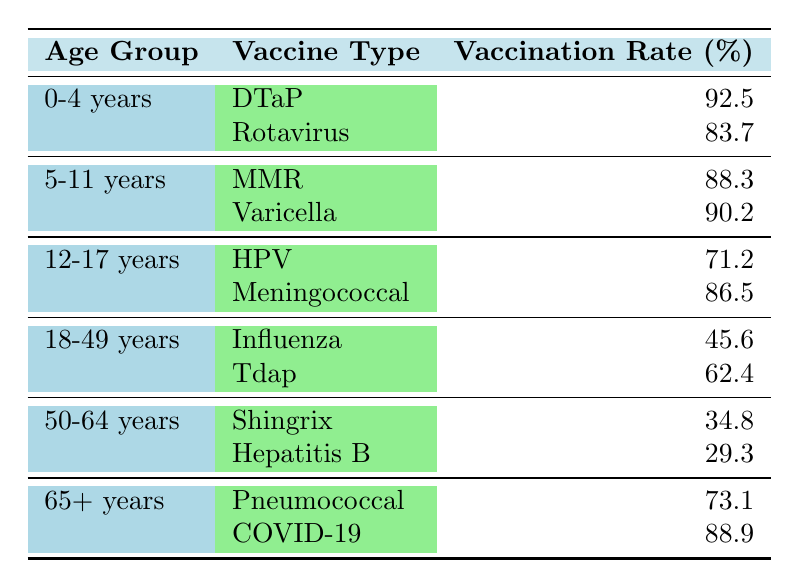What is the vaccination rate for DTaP in the 0-4 years age group? The table shows that the vaccination rate for DTaP in the 0-4 years age group is listed directly as 92.5%.
Answer: 92.5% Which age group has the highest vaccination rate for Varicella? Varicella's vaccination rate is listed under the 5-11 years age group at 90.2%, which is the highest among the listed age groups for this vaccine.
Answer: 5-11 years What is the average vaccination rate for the 18-49 years age group? The vaccination rates for the 18-49 years age group are 45.6% for Influenza and 62.4% for Tdap. The average is calculated as (45.6 + 62.4) / 2 = 54%.
Answer: 54% Is the vaccination rate for HPV higher or lower than that for Meningococcal in the 12-17 years age group? The rate for HPV is 71.2% while Meningococcal is 86.5%. Since 71.2% is less than 86.5%, the HPV rate is lower.
Answer: Lower What are the two vaccines received by the 65+ years age group? The table lists Pneumococcal and COVID-19 for the 65+ years age group.
Answer: Pneumococcal and COVID-19 Which age group has the lowest overall vaccination rates? In the 50-64 years age group, both vaccines (Shingrix at 34.8% and Hepatitis B at 29.3%) have the lowest rates compared to other age groups.
Answer: 50-64 years If you combine the vaccination rates for 0-4 years, what is the total? The total is found by adding the two rates for the 0-4 age group: 92.5% (DTaP) + 83.7% (Rotavirus) = 176.2%.
Answer: 176.2% Which vaccine has the highest vaccination rate among all age groups? Analyzing the table, DTaP at 92.5% has the highest vaccination rate compared to all other vaccines listed.
Answer: DTaP Is the vaccination rate for COVID-19 in the 65+ years age group over 85%? The table indicates that the COVID-19 vaccination rate for the 65+ years age group is 88.9%, which is indeed over 85%.
Answer: Yes What is the difference in vaccination rates between the highest and lowest vaccine types for the 50-64 years age group? The highest vaccination rate for the 50-64 years age group is 34.8% (Shingrix) and the lowest is 29.3% (Hepatitis B). The difference is 34.8% - 29.3% = 5.5%.
Answer: 5.5% 